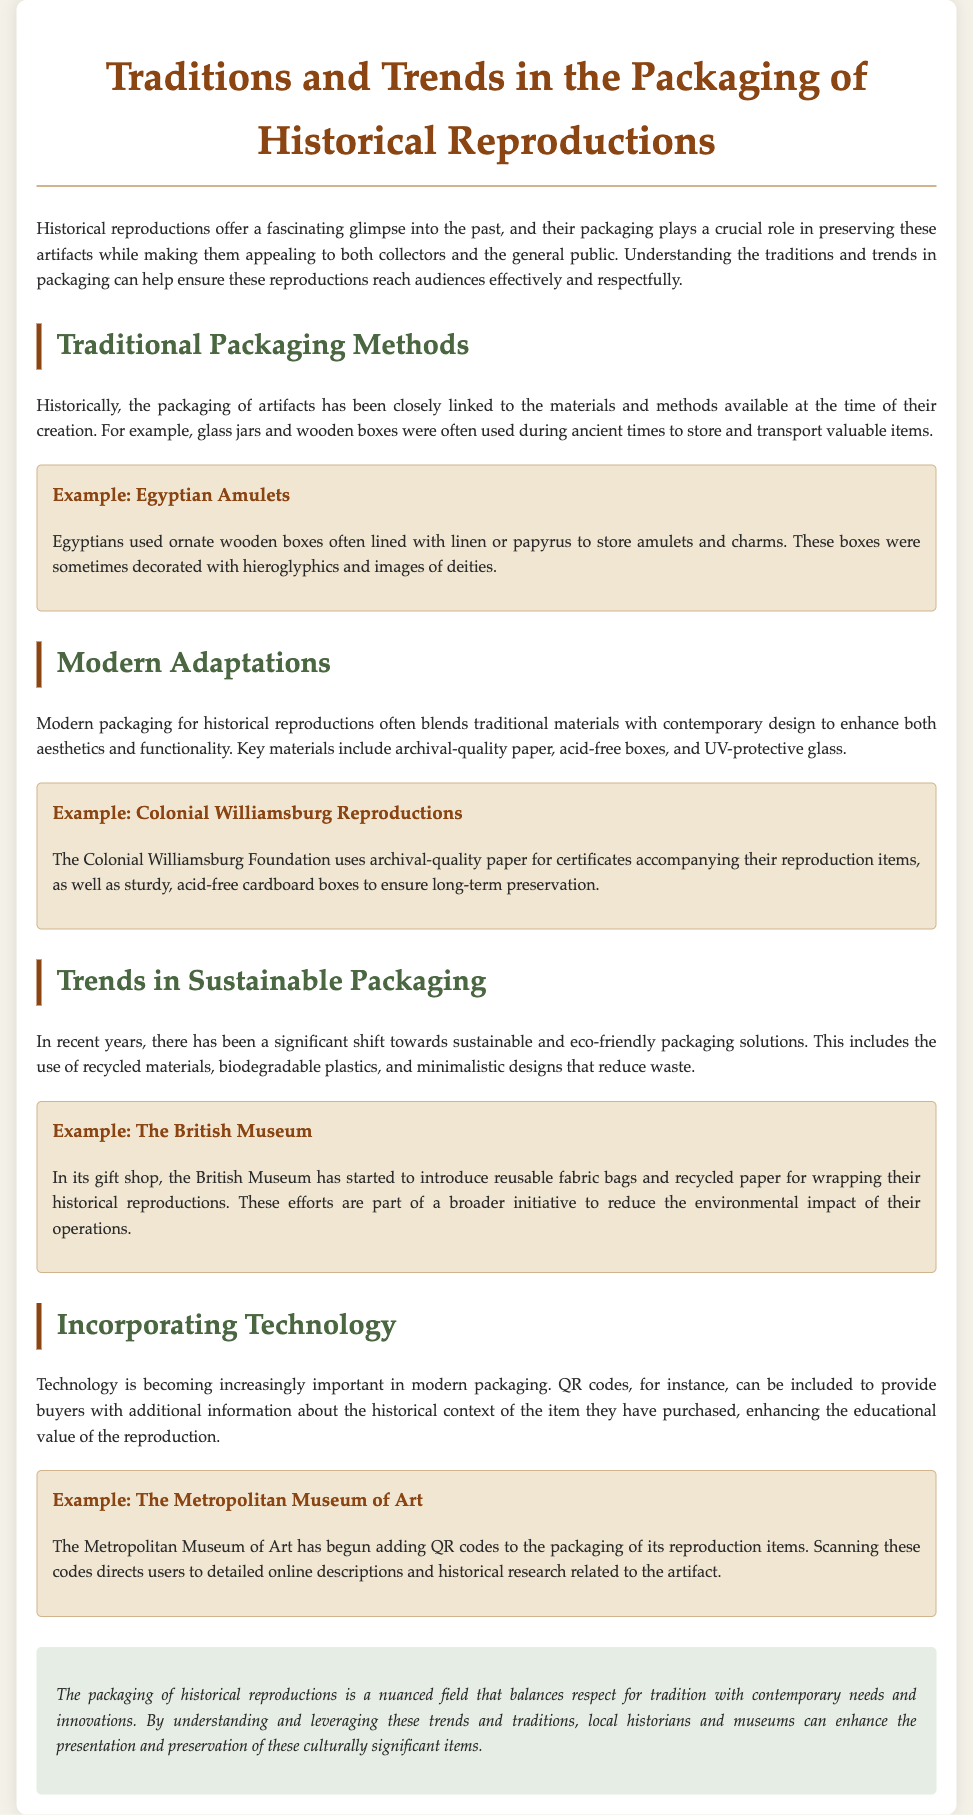what is the title of the document? The title of the document is provided in the main header at the top of the page.
Answer: Traditions and Trends in the Packaging of Historical Reproductions what materials were commonly used in historical packaging? The document mentions the materials and methods historically linked to packaging throughout the ancient times.
Answer: Glass jars and wooden boxes which historical figure is associated with the example of ornate wooden boxes? The example given in the document refers to a specific civilization known for ornate wooden boxes.
Answer: Egyptians what type of paper does the Colonial Williamsburg Foundation use for accompanying certificates? The document specifies the type of paper used for certificates in a particular modern adaptation example.
Answer: Archival-quality paper name one sustainable packaging trend mentioned in the document. The document outlines recent shifts towards sustainable practices and lists various approaches in the packaging sector.
Answer: Recycled materials what technology is increasingly incorporated in modern packaging? The document references a particular technological innovation used to enhance consumer experience with historical reproductions.
Answer: QR codes which museum introduced reusable fabric bags for its historical reproductions? The document provides an example of a specific institution that actively promotes sustainable packaging in its gift shop.
Answer: The British Museum what does the conclusion emphasize about the packaging of historical reproductions? The conclusion of the document highlights a key aspect regarding the relationship between tradition and modern needs in packaging.
Answer: A nuanced field 